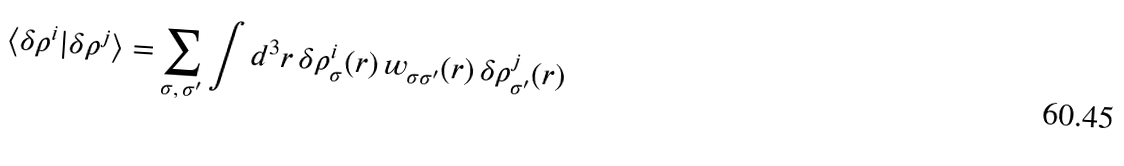<formula> <loc_0><loc_0><loc_500><loc_500>\langle \delta \rho ^ { i } | \delta \rho ^ { j } \rangle = \sum _ { \sigma , \, \sigma ^ { \prime } } \int d ^ { 3 } r \, \delta \rho _ { \sigma } ^ { i } ( r ) \, w _ { \sigma \sigma ^ { \prime } } ( r ) \, \delta \rho _ { \sigma ^ { \prime } } ^ { j } ( r )</formula> 